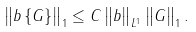Convert formula to latex. <formula><loc_0><loc_0><loc_500><loc_500>\left \| b \left \{ G \right \} \right \| _ { 1 } \leq C \left \| b \right \| _ { L ^ { 1 } } \left \| G \right \| _ { 1 } .</formula> 